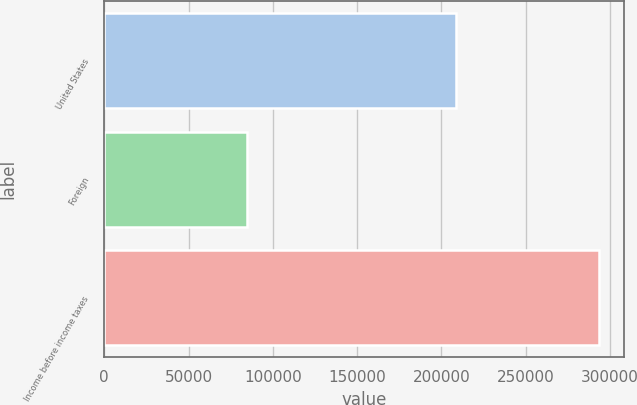<chart> <loc_0><loc_0><loc_500><loc_500><bar_chart><fcel>United States<fcel>Foreign<fcel>Income before income taxes<nl><fcel>208926<fcel>84960<fcel>293886<nl></chart> 